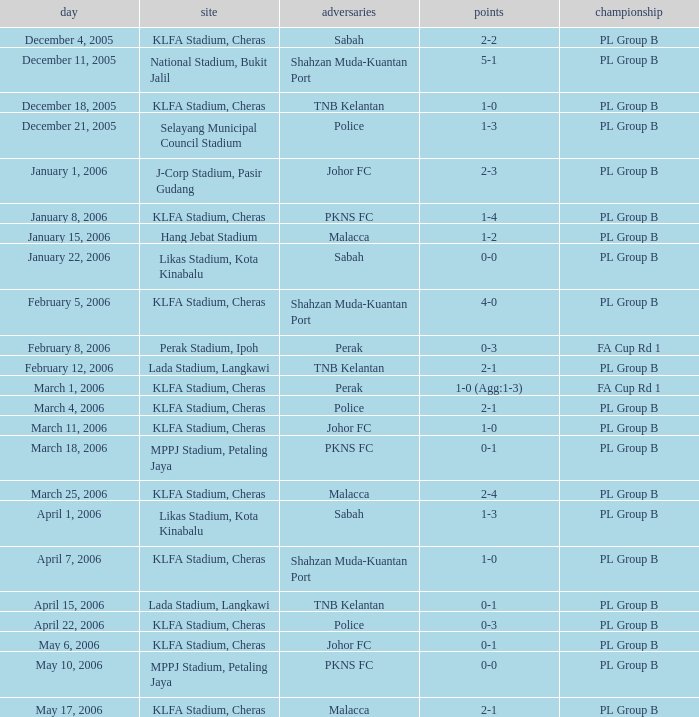Which Date has a Competition of pl group b, and Opponents of police, and a Venue of selayang municipal council stadium? December 21, 2005. 